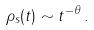Convert formula to latex. <formula><loc_0><loc_0><loc_500><loc_500>\rho _ { s } ( t ) \sim t ^ { - \theta } \, .</formula> 